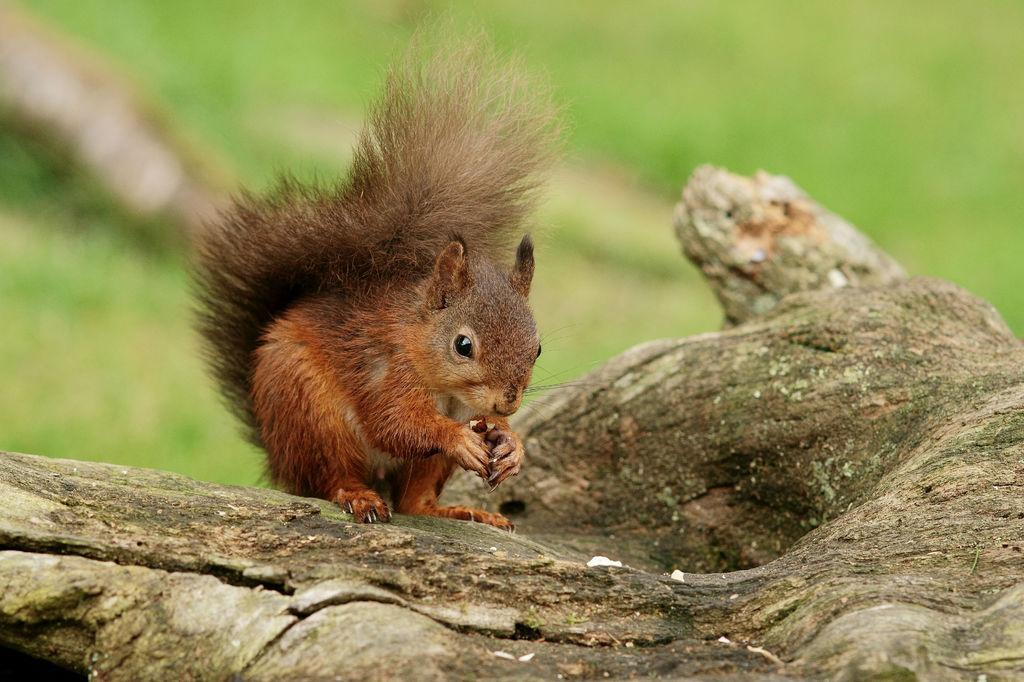What type of animal is in the image? There is a fox squirrel in the image. What is the fox squirrel standing on? The fox squirrel is on wood. What is the fox squirrel holding in the image? The fox squirrel is holding a nut. What can be seen in the background of the image? There is green grass in the background of the image. What type of discussion is taking place between the girl and the fox squirrel in the image? There is no girl present in the image, and therefore no discussion can be observed. 